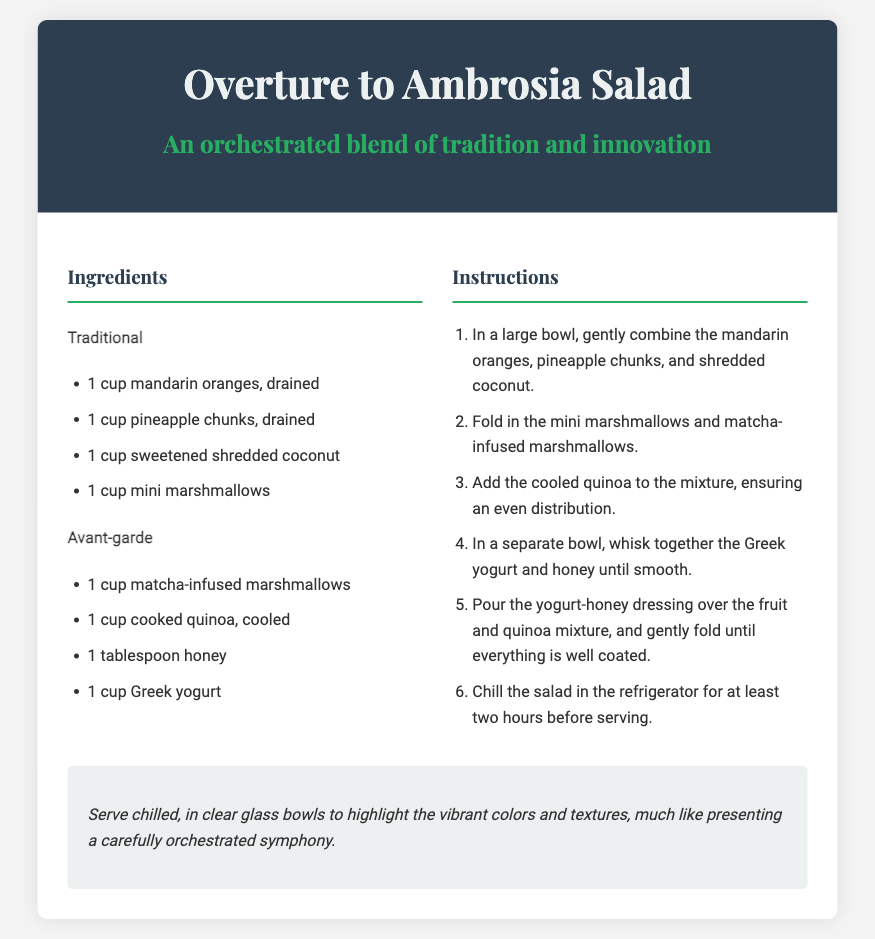What is the title of the recipe? The title of the recipe is the main heading in the document.
Answer: Overture to Ambrosia Salad How many cups of mandarin oranges are needed? The ingredients list specifies the amount of mandarin oranges required.
Answer: 1 cup What type of yogurt is used in the recipe? The ingredients section includes the specific type of yogurt for the salad.
Answer: Greek yogurt What is the first step in the instructions? The instructions list the steps to prepare the salad, starting with the initial action.
Answer: In a large bowl, gently combine the mandarin oranges, pineapple chunks, and shredded coconut How long should the salad be chilled? The instructions indicate the chilling time necessary before serving.
Answer: At least two hours What is a suggested way to serve the salad? The serving suggestion provides ideas on how to present the dish beautifully.
Answer: In clear glass bowls How many cups of avant-garde marshmallows are included? The ingredients list specifies the quantity of matcha-infused marshmallows needed.
Answer: 1 cup What ingredient is used as a sweetener in the recipe? The ingredients list includes a component for sweetness in the salad.
Answer: Honey What is the purpose of the quinoa in the recipe? The instructions and ingredients hint that quinoa contributes to the mixture’s texture and composition.
Answer: Ensuring an even distribution 